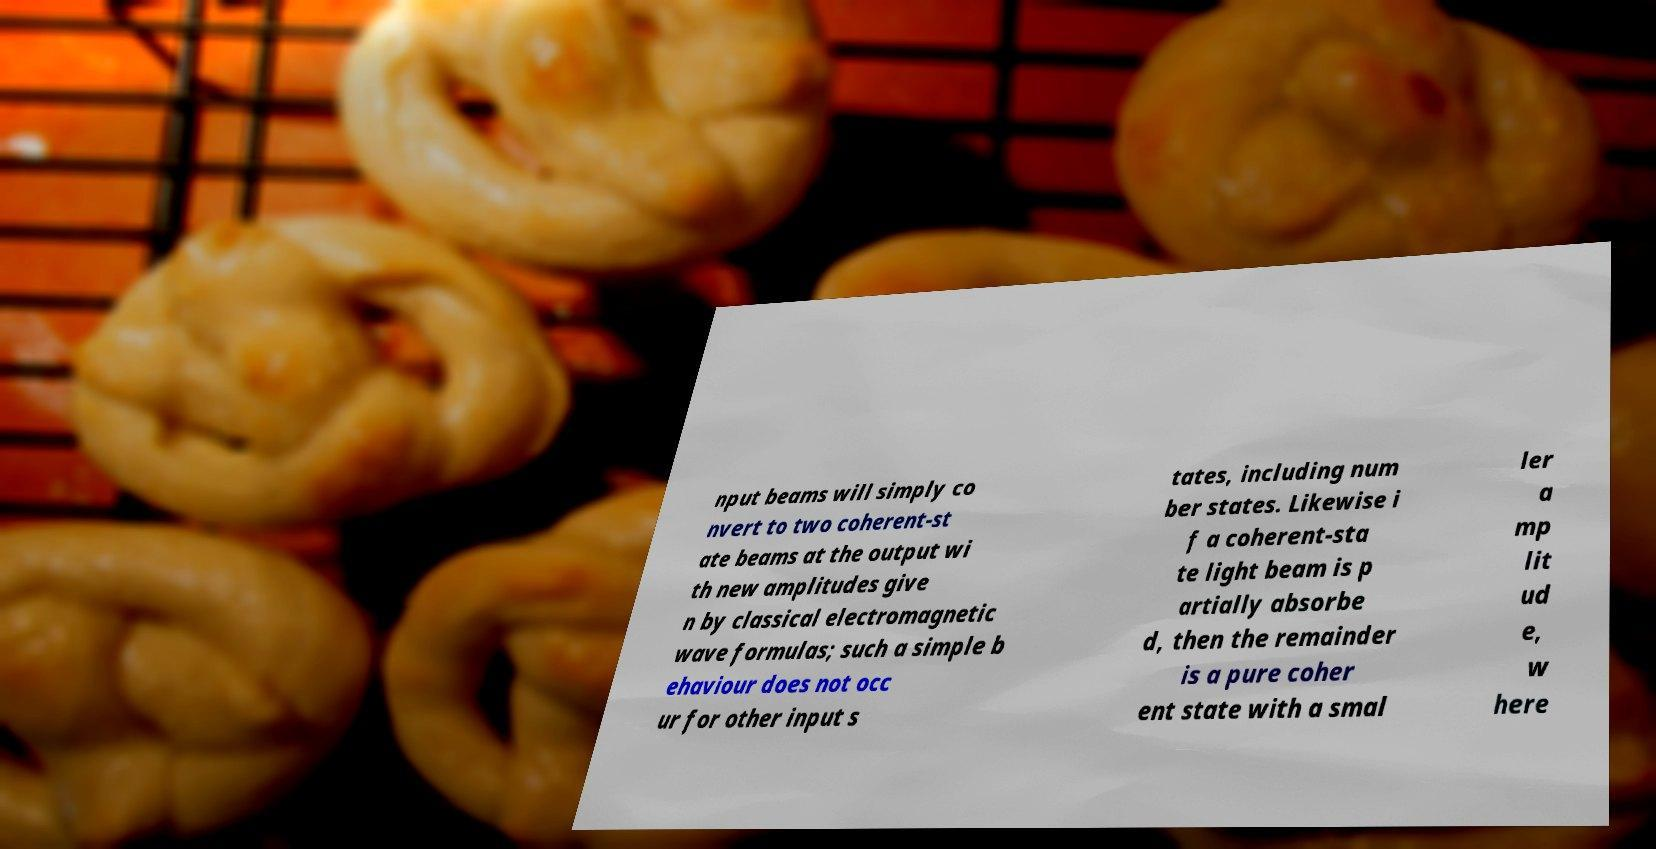What messages or text are displayed in this image? I need them in a readable, typed format. nput beams will simply co nvert to two coherent-st ate beams at the output wi th new amplitudes give n by classical electromagnetic wave formulas; such a simple b ehaviour does not occ ur for other input s tates, including num ber states. Likewise i f a coherent-sta te light beam is p artially absorbe d, then the remainder is a pure coher ent state with a smal ler a mp lit ud e, w here 